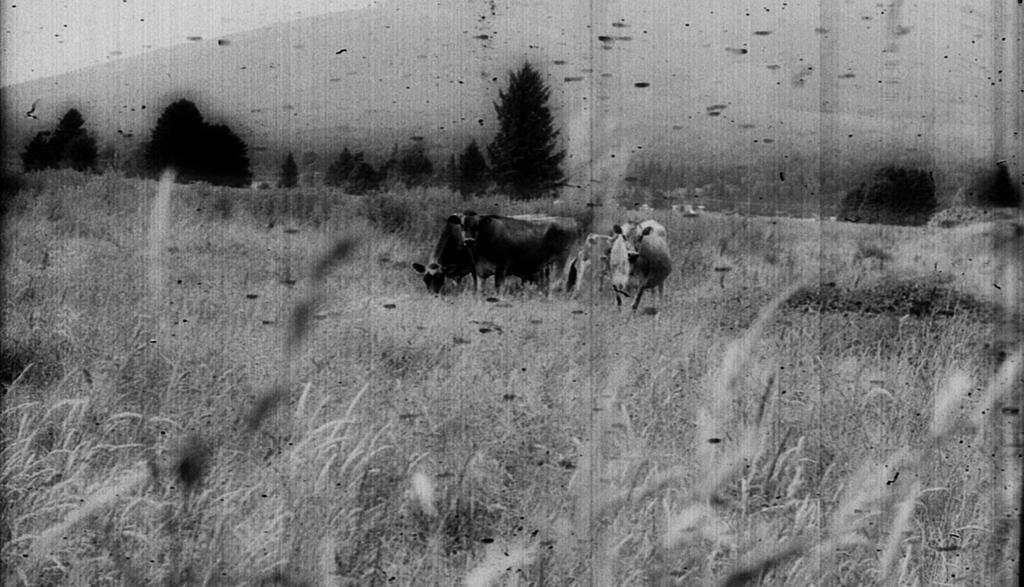How would you summarize this image in a sentence or two? This is a black and white photo. In the center of the image we can see the cows. In the background of the image we can see the trees, plants. At the top of the image we can see the sky. 